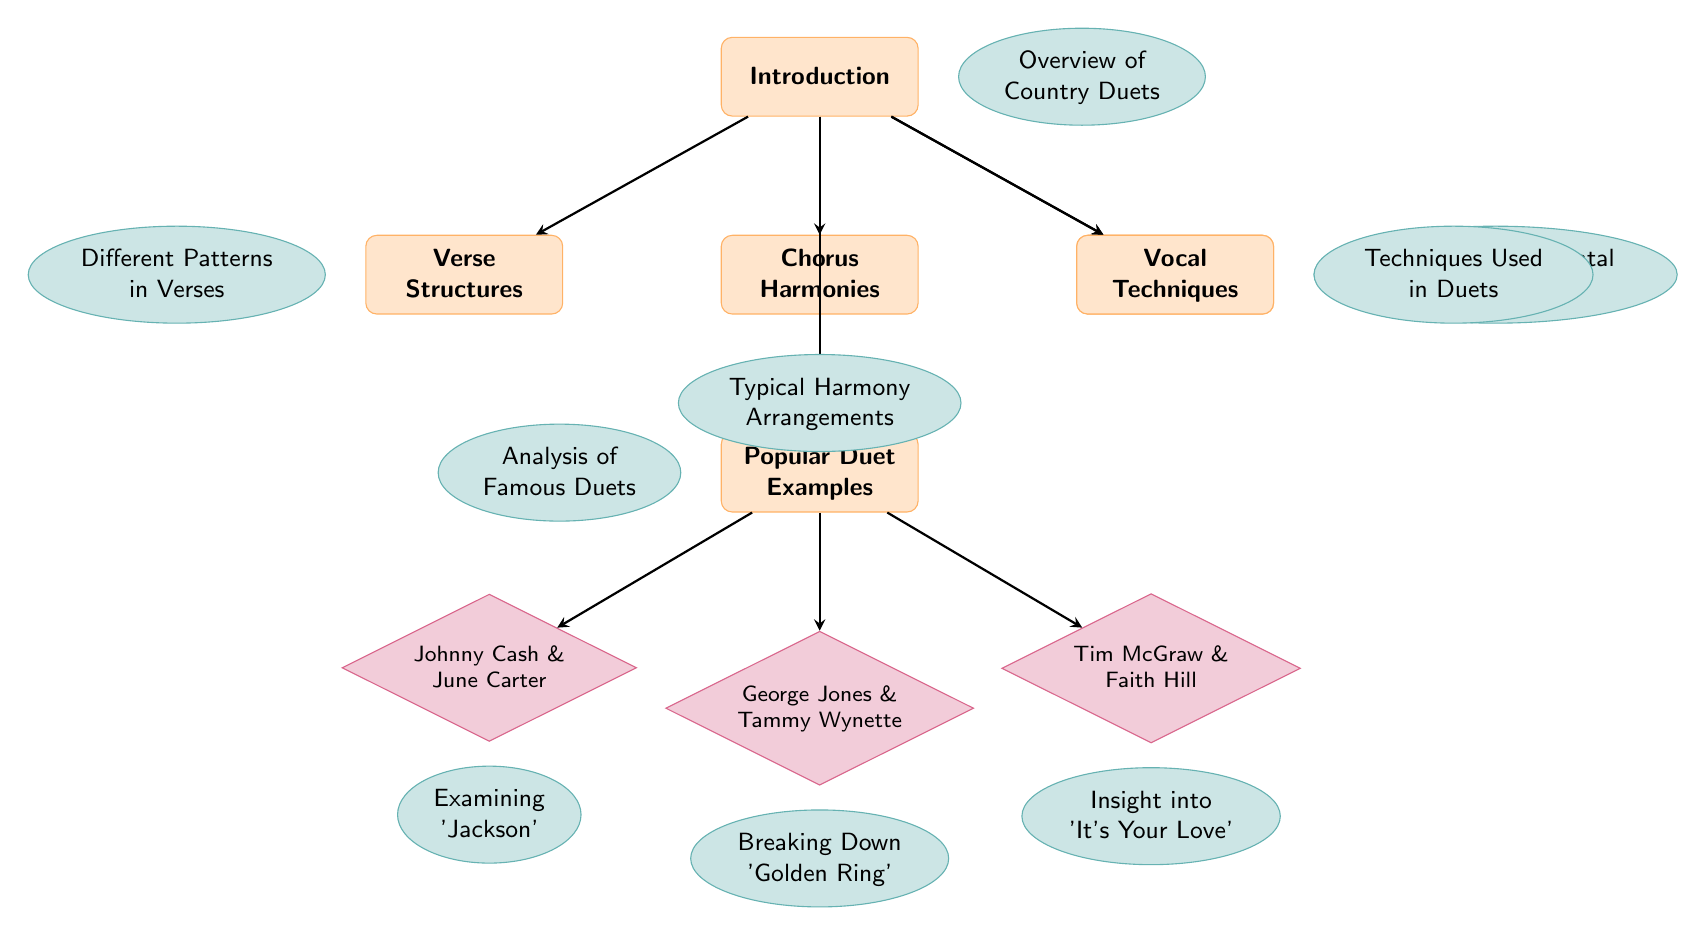What are the main topics covered in the diagram? The main topics are represented as rectangles at the top level of the diagram. They include "Introduction," "Verse Structures," "Chorus Harmonies," "Instrumental Breaks," "Vocal Techniques," and "Popular Duet Examples."
Answer: Introduction, Verse Structures, Chorus Harmonies, Instrumental Breaks, Vocal Techniques, Popular Duet Examples How many examples of popular duets are listed in the diagram? The examples are shown as diamond shapes connected to the "Popular Duet Examples" node. There are three examples: Johnny Cash & June Carter, George Jones & Tammy Wynette, and Tim McGraw & Faith Hill.
Answer: Three Which duet is associated with the examination of 'Jackson'? This information can be retrieved from the node structure; the example node for "Johnny Cash & June Carter" has a subtopic indicating the analysis of 'Jackson.'
Answer: Johnny Cash & June Carter What type of structure is represented by 'Chorus Harmonies'? 'Chorus Harmonies' is represented as a rectangle in the diagram and is connected to subtopics that describe the typical harmony arrangements.
Answer: Rectangle Which main topic connects to 'Vocal Techniques'? The 'Vocal Techniques' topic is a main topic that connects to other aspects of the diagram; it has an arrow directed from the 'Introduction' node leading to it.
Answer: Introduction What type of nodes are used to represent examples of duets? The examples of duets are represented by diamond-shaped nodes, which indicate they are specific case studies within the broader structure of country duets.
Answer: Diamond-shaped nodes How is the 'Overview of Country Duets' positionally connected to the diagram? The 'Overview of Country Duets' is a subtopic that is placed to the right of the 'Introduction' node, showing it supports the introduction discussion.
Answer: To the right of the Introduction Describe the relationship between 'Chorus Harmonies' and 'Typical Harmony Arrangements.' 'Chorus Harmonies' is connected to 'Typical Harmony Arrangements' with a direct downward arrow, suggesting that the latter delves deeper into the specifics of the former's topic.
Answer: Direct connection with downward arrow 